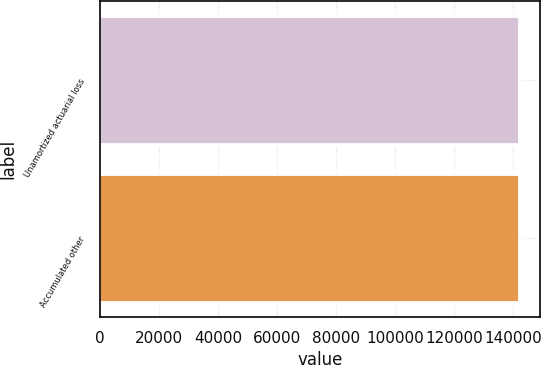Convert chart to OTSL. <chart><loc_0><loc_0><loc_500><loc_500><bar_chart><fcel>Unamortized actuarial loss<fcel>Accumulated other<nl><fcel>141912<fcel>141912<nl></chart> 